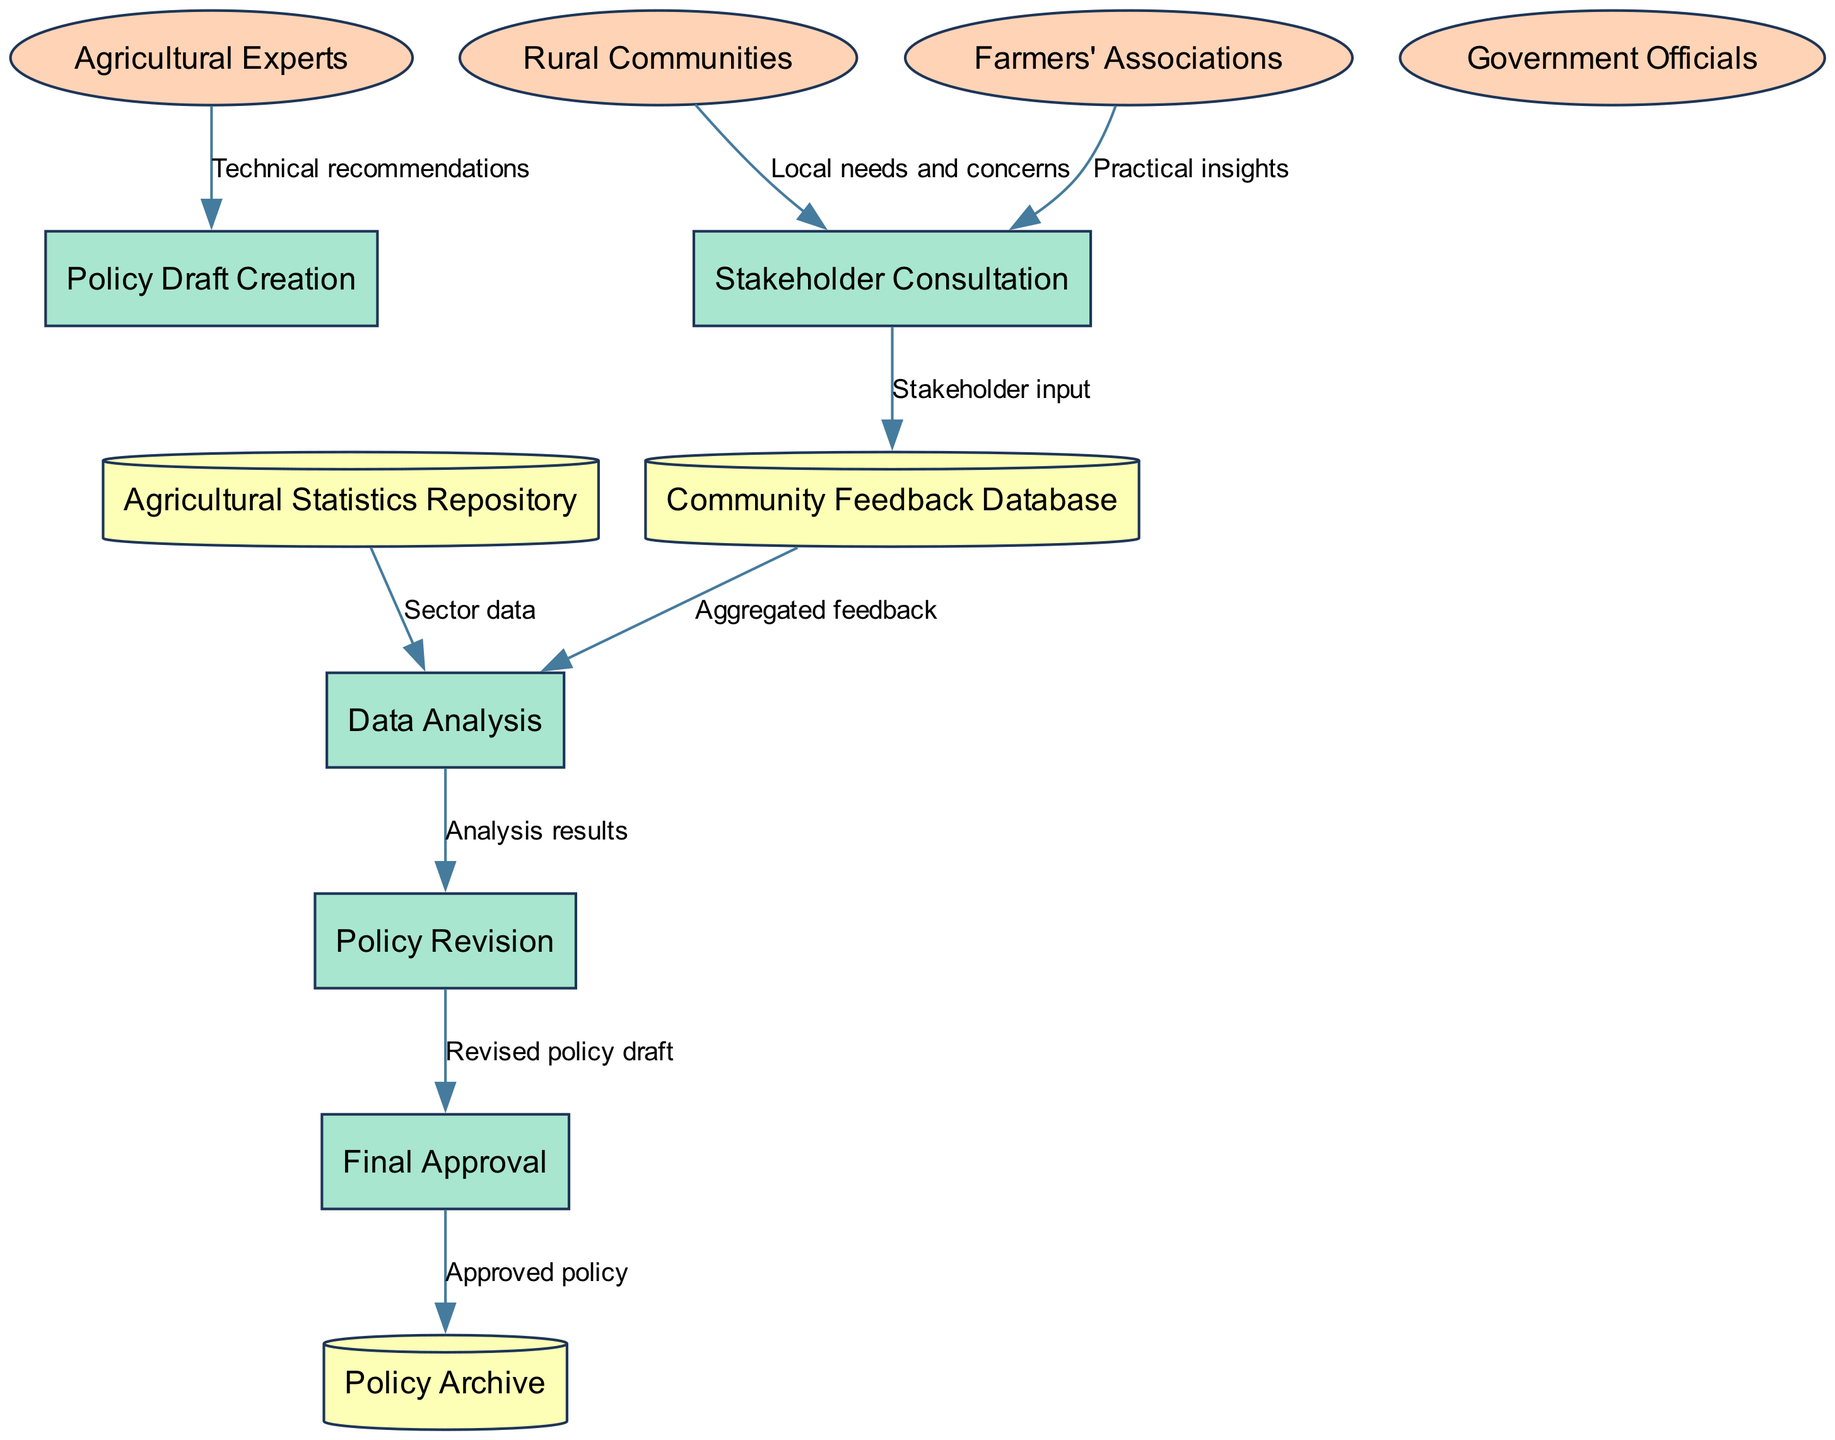What are the external entities involved in the policy development process? The external entities are listed in the diagram under external entities, which include Rural Communities, Agricultural Experts, Government Officials, and Farmers' Associations.
Answer: Rural Communities, Agricultural Experts, Government Officials, Farmers' Associations How many processes are in the diagram? By counting the items listed under processes, there are five processes involved in the policy development process.
Answer: 5 What is the flow of information from Rural Communities to Stakeholder Consultation? The flow labeled "Local needs and concerns" shows that information from Rural Communities is directed to the Stakeholder Consultation process.
Answer: Local needs and concerns Which process receives "Technical recommendations"? The diagram states that the Policy Draft Creation process receives Technical recommendations from Agricultural Experts, indicating the source of this information.
Answer: Policy Draft Creation What does the Community Feedback Database provide to Data Analysis? The diagram indicates that the Community Feedback Database sends Aggregated feedback to Data Analysis, which is crucial for further evaluation.
Answer: Aggregated feedback How many data stores are there in the diagram? The data stores are specifically labeled in the diagram, and by counting these, we find there are three data stores mentioned: Community Feedback Database, Agricultural Statistics Repository, and Policy Archive.
Answer: 3 What is the final output of the policy development process? The diagram shows that the Final Approval process outputs the Approved policy to the Policy Archive, which represents the conclusion of the development process.
Answer: Approved policy What is the connection between Data Analysis and Policy Revision? The edge labeled "Analysis results" connects Data Analysis to the Policy Revision process, indicating that the analysis conducted influences policy modifications.
Answer: Analysis results Which stakeholders provide input during the Stakeholder Consultation process? The diagram shows that both Rural Communities and Farmers' Associations contribute insights during the Stakeholder Consultation, emphasizing their participation in the policy development.
Answer: Rural Communities, Farmers' Associations 